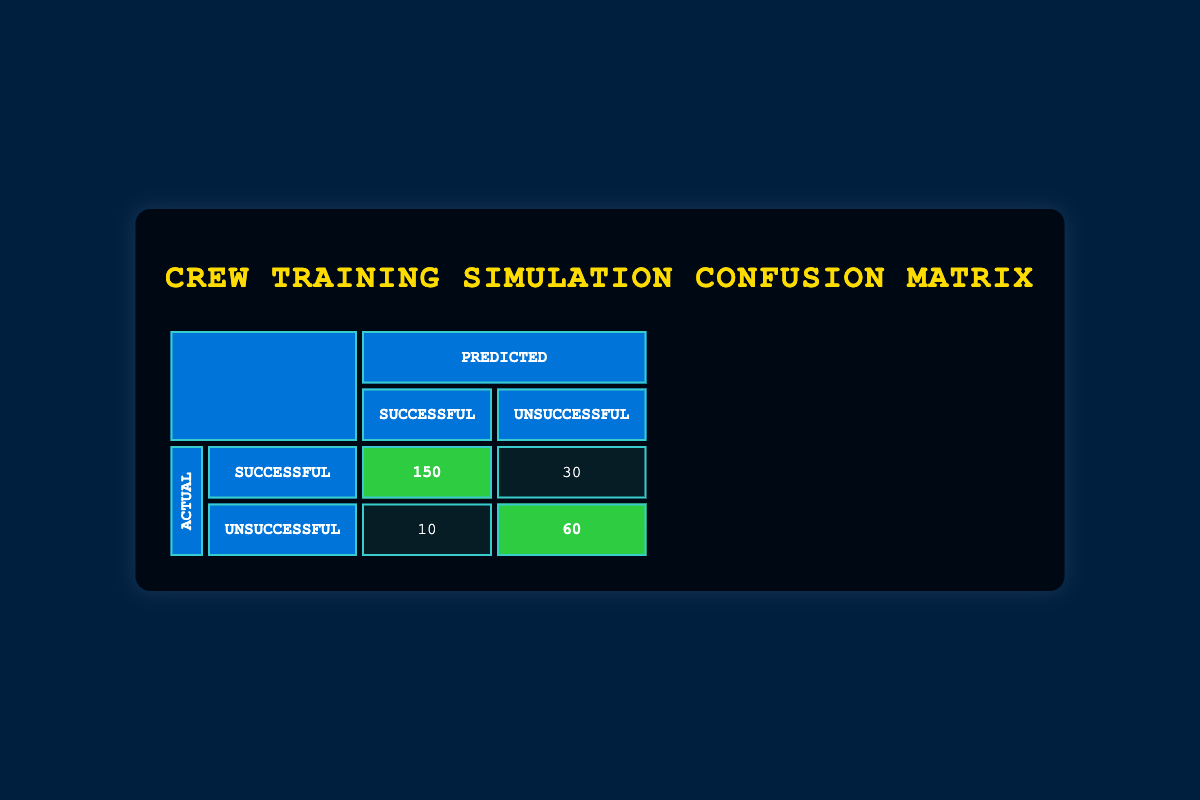What is the total number of simulations that resulted in a Successful outcome? To find the total number of Successful outcomes, we look at the first row of the table, which states that there were 150 Successful predictions for Successful actuals, and the second row states there were 10 Successful predictions for Unsuccessful actuals. Adding these values gives us 150 + 10 = 160.
Answer: 160 What is the number of Unsuccessful predictions that were actually Successful? According to the table, there are 10 cases where the actual outcome was Successful, but the prediction was Unsuccessful. This value is found directly in the table.
Answer: 10 How many total simulations were evaluated in this confusion matrix? The total number of simulations can be calculated by summing all the counts in the table: 150 (Successful, Successful) + 30 (Successful, Unsuccessful) + 10 (Unsuccessful, Successful) + 60 (Unsuccessful, Unsuccessful) equals 250.
Answer: 250 Is the number of Successful outcomes greater than the number of Unsuccessful outcomes? To evaluate this, we need to compare the total counts of Successful and Unsuccessful outcomes. The total number of Successful outcomes is 160, and the total number of Unsuccessful outcomes is 90 (30 + 60). Since 160 is greater than 90, the answer is yes.
Answer: Yes What percentage of the predicted Successful outcomes were actually Successful? We find the predicted Successful outcomes by adding the Successful predictions (150 for Successful and 10 for Unsuccessful) which equals 160. The successful outcomes from these predictions are 150. The percentage is then calculated as (150/160)*100 which equals 93.75%.
Answer: 93.75% 